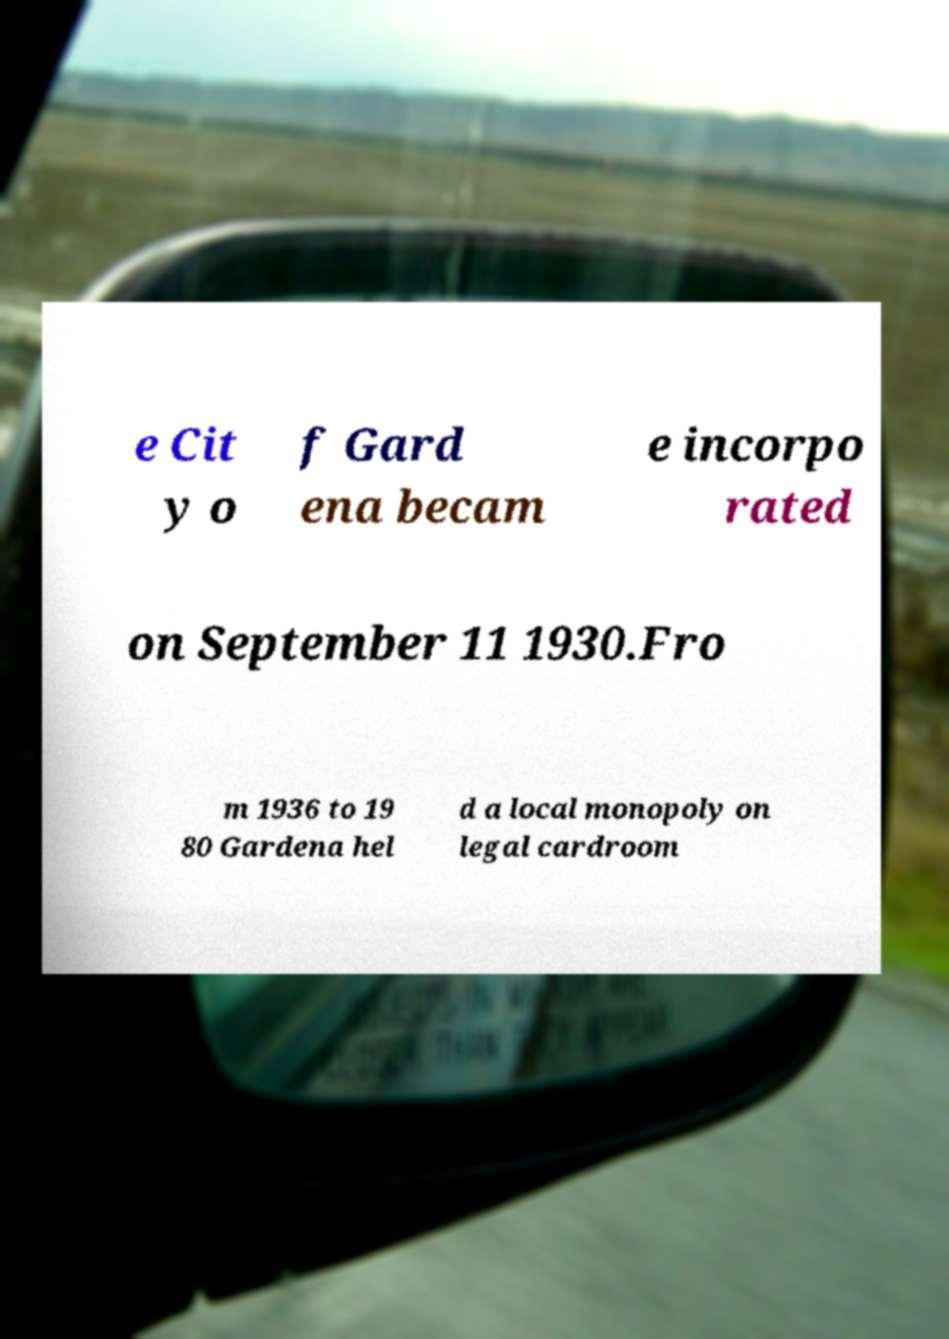What messages or text are displayed in this image? I need them in a readable, typed format. e Cit y o f Gard ena becam e incorpo rated on September 11 1930.Fro m 1936 to 19 80 Gardena hel d a local monopoly on legal cardroom 